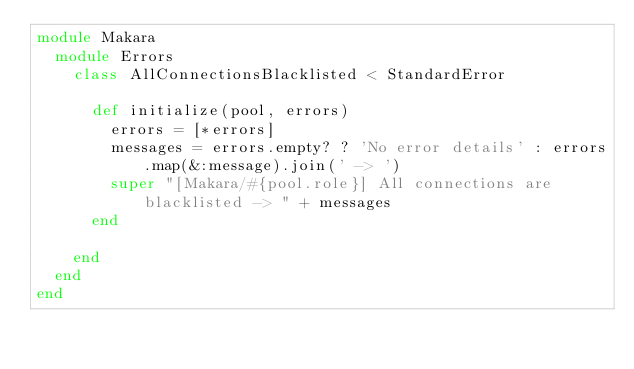Convert code to text. <code><loc_0><loc_0><loc_500><loc_500><_Ruby_>module Makara
  module Errors
    class AllConnectionsBlacklisted < StandardError

      def initialize(pool, errors)
        errors = [*errors]
        messages = errors.empty? ? 'No error details' : errors.map(&:message).join(' -> ')
        super "[Makara/#{pool.role}] All connections are blacklisted -> " + messages
      end

    end
  end
end
</code> 